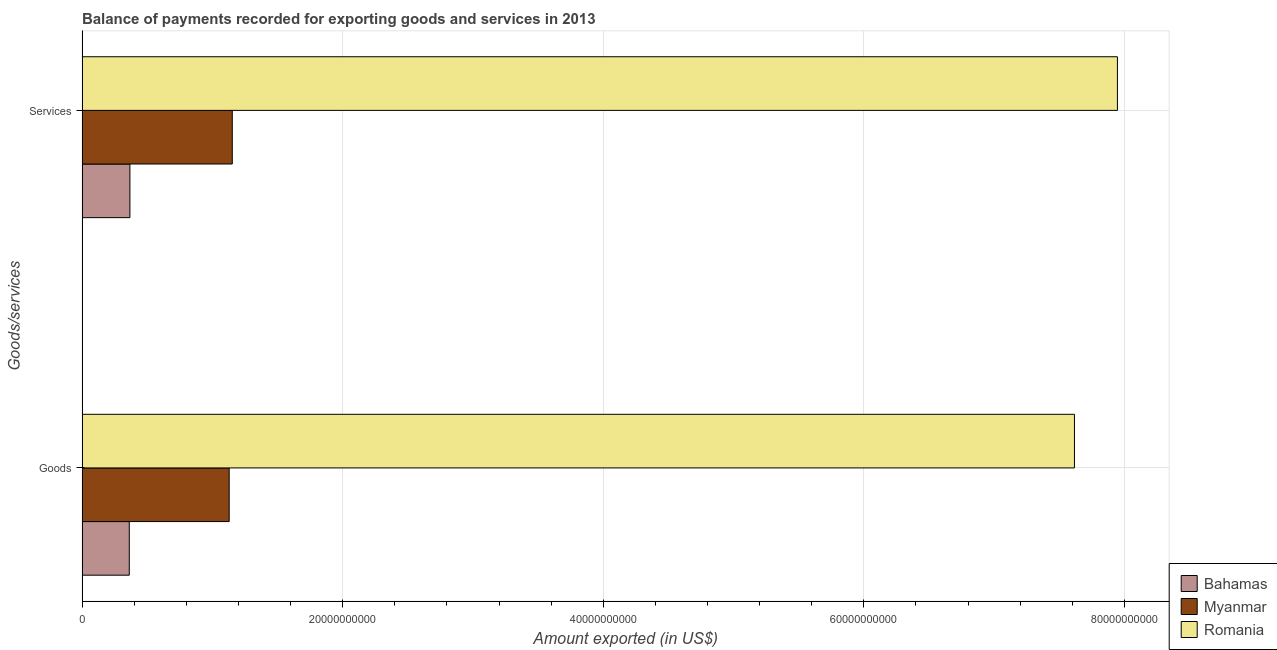Are the number of bars per tick equal to the number of legend labels?
Your answer should be compact. Yes. How many bars are there on the 2nd tick from the bottom?
Provide a succinct answer. 3. What is the label of the 1st group of bars from the top?
Offer a very short reply. Services. What is the amount of services exported in Romania?
Your answer should be very brief. 7.95e+1. Across all countries, what is the maximum amount of services exported?
Offer a very short reply. 7.95e+1. Across all countries, what is the minimum amount of services exported?
Ensure brevity in your answer.  3.67e+09. In which country was the amount of services exported maximum?
Offer a very short reply. Romania. In which country was the amount of services exported minimum?
Provide a short and direct response. Bahamas. What is the total amount of services exported in the graph?
Your answer should be very brief. 9.47e+1. What is the difference between the amount of services exported in Myanmar and that in Romania?
Make the answer very short. -6.79e+1. What is the difference between the amount of goods exported in Romania and the amount of services exported in Myanmar?
Give a very brief answer. 6.46e+1. What is the average amount of services exported per country?
Your response must be concise. 3.16e+1. What is the difference between the amount of services exported and amount of goods exported in Romania?
Offer a very short reply. 3.30e+09. In how many countries, is the amount of goods exported greater than 36000000000 US$?
Your answer should be very brief. 1. What is the ratio of the amount of goods exported in Bahamas to that in Myanmar?
Your response must be concise. 0.32. Is the amount of goods exported in Bahamas less than that in Myanmar?
Ensure brevity in your answer.  Yes. What does the 3rd bar from the top in Services represents?
Your answer should be compact. Bahamas. What does the 3rd bar from the bottom in Services represents?
Keep it short and to the point. Romania. How many countries are there in the graph?
Offer a terse response. 3. Are the values on the major ticks of X-axis written in scientific E-notation?
Keep it short and to the point. No. Does the graph contain any zero values?
Make the answer very short. No. Does the graph contain grids?
Provide a succinct answer. Yes. How many legend labels are there?
Your response must be concise. 3. How are the legend labels stacked?
Your answer should be very brief. Vertical. What is the title of the graph?
Offer a very short reply. Balance of payments recorded for exporting goods and services in 2013. What is the label or title of the X-axis?
Make the answer very short. Amount exported (in US$). What is the label or title of the Y-axis?
Offer a terse response. Goods/services. What is the Amount exported (in US$) in Bahamas in Goods?
Provide a succinct answer. 3.63e+09. What is the Amount exported (in US$) in Myanmar in Goods?
Make the answer very short. 1.13e+1. What is the Amount exported (in US$) in Romania in Goods?
Keep it short and to the point. 7.62e+1. What is the Amount exported (in US$) in Bahamas in Services?
Provide a short and direct response. 3.67e+09. What is the Amount exported (in US$) in Myanmar in Services?
Your answer should be compact. 1.15e+1. What is the Amount exported (in US$) of Romania in Services?
Give a very brief answer. 7.95e+1. Across all Goods/services, what is the maximum Amount exported (in US$) of Bahamas?
Offer a terse response. 3.67e+09. Across all Goods/services, what is the maximum Amount exported (in US$) in Myanmar?
Offer a terse response. 1.15e+1. Across all Goods/services, what is the maximum Amount exported (in US$) in Romania?
Your answer should be very brief. 7.95e+1. Across all Goods/services, what is the minimum Amount exported (in US$) of Bahamas?
Give a very brief answer. 3.63e+09. Across all Goods/services, what is the minimum Amount exported (in US$) of Myanmar?
Provide a short and direct response. 1.13e+1. Across all Goods/services, what is the minimum Amount exported (in US$) in Romania?
Your answer should be very brief. 7.62e+1. What is the total Amount exported (in US$) in Bahamas in the graph?
Keep it short and to the point. 7.30e+09. What is the total Amount exported (in US$) in Myanmar in the graph?
Give a very brief answer. 2.28e+1. What is the total Amount exported (in US$) of Romania in the graph?
Provide a short and direct response. 1.56e+11. What is the difference between the Amount exported (in US$) in Bahamas in Goods and that in Services?
Offer a terse response. -4.80e+07. What is the difference between the Amount exported (in US$) of Myanmar in Goods and that in Services?
Give a very brief answer. -2.37e+08. What is the difference between the Amount exported (in US$) in Romania in Goods and that in Services?
Your response must be concise. -3.30e+09. What is the difference between the Amount exported (in US$) in Bahamas in Goods and the Amount exported (in US$) in Myanmar in Services?
Provide a succinct answer. -7.90e+09. What is the difference between the Amount exported (in US$) of Bahamas in Goods and the Amount exported (in US$) of Romania in Services?
Provide a succinct answer. -7.58e+1. What is the difference between the Amount exported (in US$) in Myanmar in Goods and the Amount exported (in US$) in Romania in Services?
Your response must be concise. -6.82e+1. What is the average Amount exported (in US$) of Bahamas per Goods/services?
Keep it short and to the point. 3.65e+09. What is the average Amount exported (in US$) of Myanmar per Goods/services?
Make the answer very short. 1.14e+1. What is the average Amount exported (in US$) in Romania per Goods/services?
Your response must be concise. 7.78e+1. What is the difference between the Amount exported (in US$) of Bahamas and Amount exported (in US$) of Myanmar in Goods?
Your answer should be very brief. -7.67e+09. What is the difference between the Amount exported (in US$) of Bahamas and Amount exported (in US$) of Romania in Goods?
Provide a succinct answer. -7.25e+1. What is the difference between the Amount exported (in US$) of Myanmar and Amount exported (in US$) of Romania in Goods?
Your answer should be compact. -6.49e+1. What is the difference between the Amount exported (in US$) in Bahamas and Amount exported (in US$) in Myanmar in Services?
Make the answer very short. -7.86e+09. What is the difference between the Amount exported (in US$) in Bahamas and Amount exported (in US$) in Romania in Services?
Your answer should be very brief. -7.58e+1. What is the difference between the Amount exported (in US$) in Myanmar and Amount exported (in US$) in Romania in Services?
Your answer should be very brief. -6.79e+1. What is the ratio of the Amount exported (in US$) of Bahamas in Goods to that in Services?
Provide a succinct answer. 0.99. What is the ratio of the Amount exported (in US$) of Myanmar in Goods to that in Services?
Keep it short and to the point. 0.98. What is the ratio of the Amount exported (in US$) in Romania in Goods to that in Services?
Your response must be concise. 0.96. What is the difference between the highest and the second highest Amount exported (in US$) of Bahamas?
Ensure brevity in your answer.  4.80e+07. What is the difference between the highest and the second highest Amount exported (in US$) in Myanmar?
Offer a very short reply. 2.37e+08. What is the difference between the highest and the second highest Amount exported (in US$) of Romania?
Make the answer very short. 3.30e+09. What is the difference between the highest and the lowest Amount exported (in US$) of Bahamas?
Offer a terse response. 4.80e+07. What is the difference between the highest and the lowest Amount exported (in US$) of Myanmar?
Provide a short and direct response. 2.37e+08. What is the difference between the highest and the lowest Amount exported (in US$) of Romania?
Give a very brief answer. 3.30e+09. 